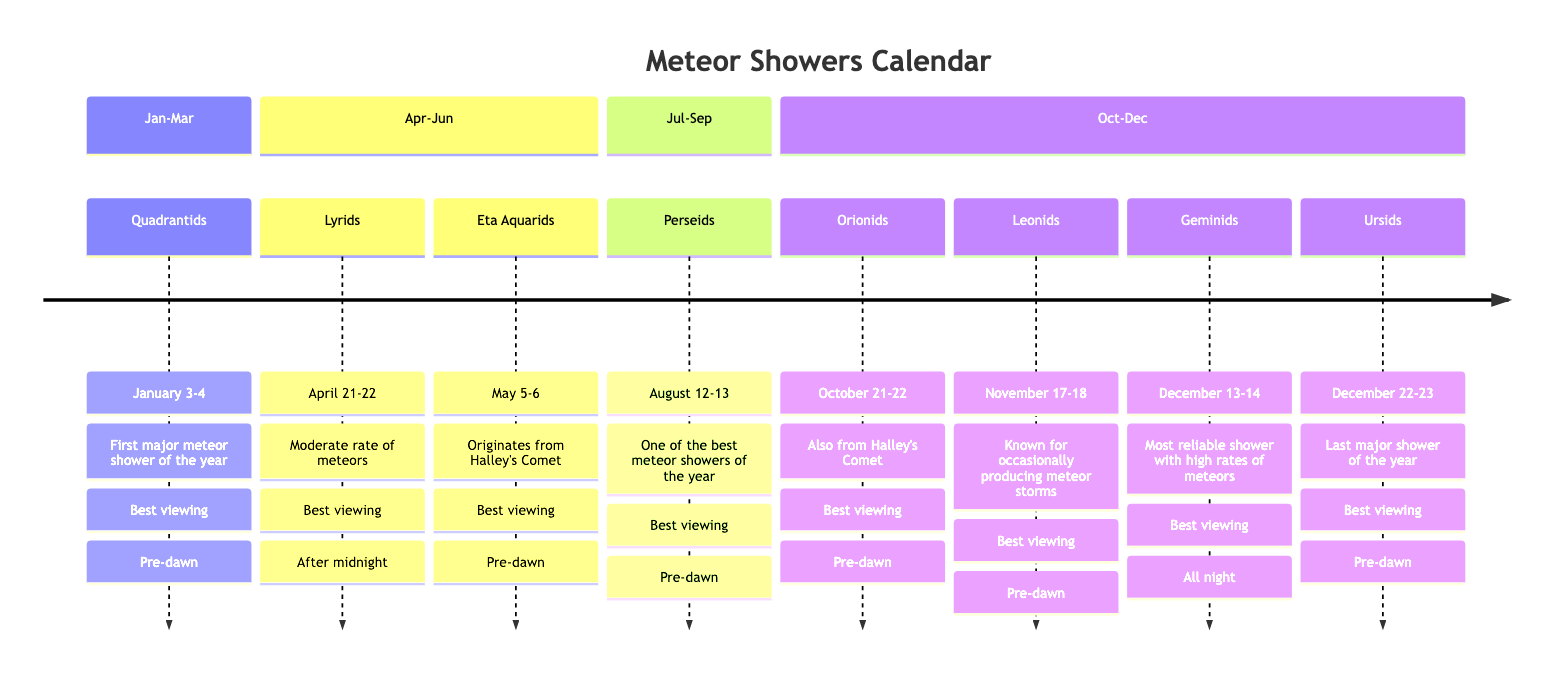What are the peak dates for the Perseids meteor shower? According to the diagram, the Perseids meteor shower peaks on August 12-13.
Answer: August 12-13 Which meteor shower occurs after the Lyrids in the calendar? Following the Lyrids, the next meteor shower listed in the diagram is the Eta Aquarids.
Answer: Eta Aquarids How many major meteor showers are there in total according to this diagram? The diagram lists a total of 7 major meteor showers across the sections.
Answer: 7 What is the best viewing time for the Geminids meteor shower? The diagram states that the best viewing time for the Geminids meteor shower is all night.
Answer: All night Which meteor shower is noted for producing meteor storms? The Leonids meteor shower is specifically mentioned in the diagram for occasionally producing meteor storms.
Answer: Leonids What is the origin of the Eta Aquarids meteor shower? The Eta Aquarids originates from Halley's Comet as noted in the diagram.
Answer: Halley's Comet Which month has the first major meteor shower of the year? January is indicated in the diagram as the month with the first major meteor shower, the Quadrantids.
Answer: January How many meteor showers have their best viewing times listed as "Pre-dawn"? There are 5 meteor showers with the best viewing times listed as "Pre-dawn" in the diagram.
Answer: 5 